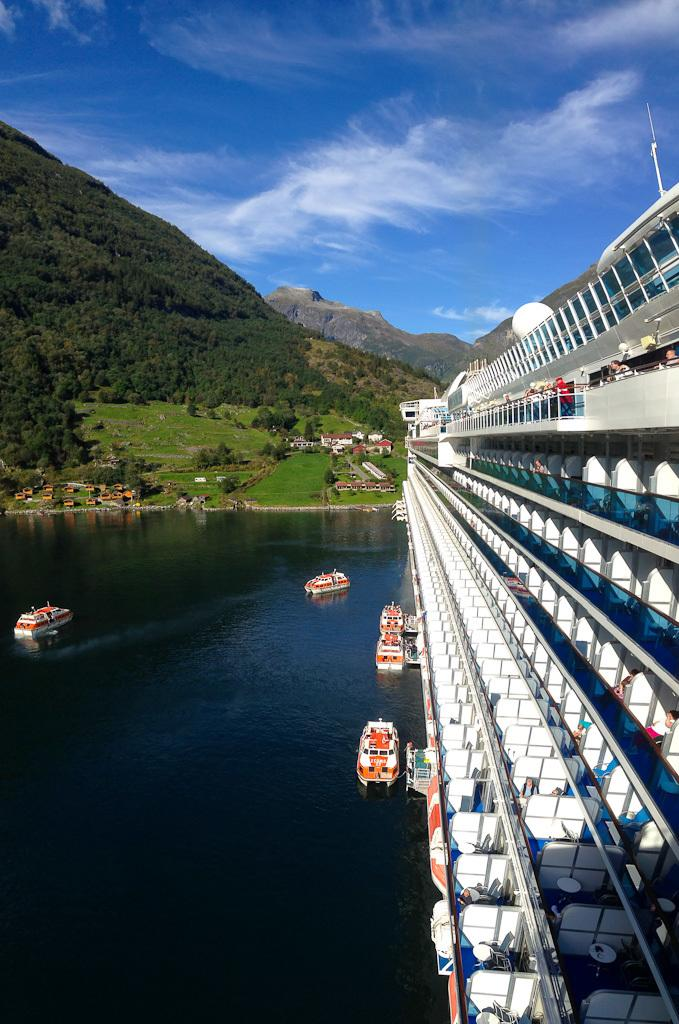What type of vehicle is the main subject in the image? There is a ship in the image. Are there any other similar vehicles in the image? Yes, there are boats in the image. Where are the ship and boats located? The ship and boats are on the water. What can be seen in the background of the image? There are houses, trees, mountains, and the sky visible in the background of the image. What color is the balloon flying over the mountains in the image? There is no balloon present in the image; it only features a ship, boats, houses, trees, mountains, and the sky. 